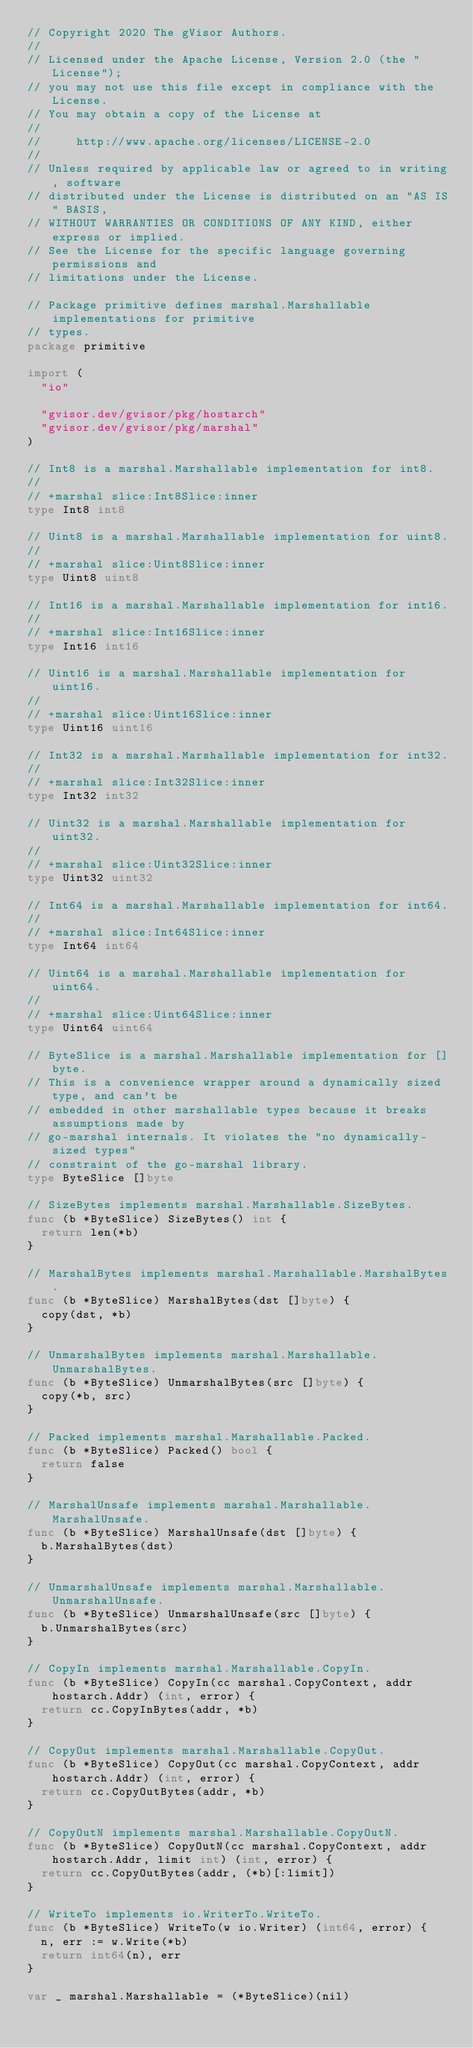Convert code to text. <code><loc_0><loc_0><loc_500><loc_500><_Go_>// Copyright 2020 The gVisor Authors.
//
// Licensed under the Apache License, Version 2.0 (the "License");
// you may not use this file except in compliance with the License.
// You may obtain a copy of the License at
//
//     http://www.apache.org/licenses/LICENSE-2.0
//
// Unless required by applicable law or agreed to in writing, software
// distributed under the License is distributed on an "AS IS" BASIS,
// WITHOUT WARRANTIES OR CONDITIONS OF ANY KIND, either express or implied.
// See the License for the specific language governing permissions and
// limitations under the License.

// Package primitive defines marshal.Marshallable implementations for primitive
// types.
package primitive

import (
	"io"

	"gvisor.dev/gvisor/pkg/hostarch"
	"gvisor.dev/gvisor/pkg/marshal"
)

// Int8 is a marshal.Marshallable implementation for int8.
//
// +marshal slice:Int8Slice:inner
type Int8 int8

// Uint8 is a marshal.Marshallable implementation for uint8.
//
// +marshal slice:Uint8Slice:inner
type Uint8 uint8

// Int16 is a marshal.Marshallable implementation for int16.
//
// +marshal slice:Int16Slice:inner
type Int16 int16

// Uint16 is a marshal.Marshallable implementation for uint16.
//
// +marshal slice:Uint16Slice:inner
type Uint16 uint16

// Int32 is a marshal.Marshallable implementation for int32.
//
// +marshal slice:Int32Slice:inner
type Int32 int32

// Uint32 is a marshal.Marshallable implementation for uint32.
//
// +marshal slice:Uint32Slice:inner
type Uint32 uint32

// Int64 is a marshal.Marshallable implementation for int64.
//
// +marshal slice:Int64Slice:inner
type Int64 int64

// Uint64 is a marshal.Marshallable implementation for uint64.
//
// +marshal slice:Uint64Slice:inner
type Uint64 uint64

// ByteSlice is a marshal.Marshallable implementation for []byte.
// This is a convenience wrapper around a dynamically sized type, and can't be
// embedded in other marshallable types because it breaks assumptions made by
// go-marshal internals. It violates the "no dynamically-sized types"
// constraint of the go-marshal library.
type ByteSlice []byte

// SizeBytes implements marshal.Marshallable.SizeBytes.
func (b *ByteSlice) SizeBytes() int {
	return len(*b)
}

// MarshalBytes implements marshal.Marshallable.MarshalBytes.
func (b *ByteSlice) MarshalBytes(dst []byte) {
	copy(dst, *b)
}

// UnmarshalBytes implements marshal.Marshallable.UnmarshalBytes.
func (b *ByteSlice) UnmarshalBytes(src []byte) {
	copy(*b, src)
}

// Packed implements marshal.Marshallable.Packed.
func (b *ByteSlice) Packed() bool {
	return false
}

// MarshalUnsafe implements marshal.Marshallable.MarshalUnsafe.
func (b *ByteSlice) MarshalUnsafe(dst []byte) {
	b.MarshalBytes(dst)
}

// UnmarshalUnsafe implements marshal.Marshallable.UnmarshalUnsafe.
func (b *ByteSlice) UnmarshalUnsafe(src []byte) {
	b.UnmarshalBytes(src)
}

// CopyIn implements marshal.Marshallable.CopyIn.
func (b *ByteSlice) CopyIn(cc marshal.CopyContext, addr hostarch.Addr) (int, error) {
	return cc.CopyInBytes(addr, *b)
}

// CopyOut implements marshal.Marshallable.CopyOut.
func (b *ByteSlice) CopyOut(cc marshal.CopyContext, addr hostarch.Addr) (int, error) {
	return cc.CopyOutBytes(addr, *b)
}

// CopyOutN implements marshal.Marshallable.CopyOutN.
func (b *ByteSlice) CopyOutN(cc marshal.CopyContext, addr hostarch.Addr, limit int) (int, error) {
	return cc.CopyOutBytes(addr, (*b)[:limit])
}

// WriteTo implements io.WriterTo.WriteTo.
func (b *ByteSlice) WriteTo(w io.Writer) (int64, error) {
	n, err := w.Write(*b)
	return int64(n), err
}

var _ marshal.Marshallable = (*ByteSlice)(nil)
</code> 